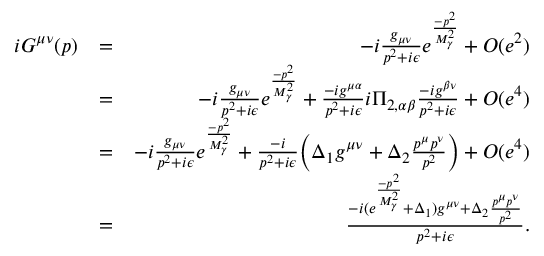<formula> <loc_0><loc_0><loc_500><loc_500>\begin{array} { r l r } { i G ^ { \mu \nu } ( p ) } & { = } & { - i \frac { g _ { \mu \nu } } { p ^ { 2 } + i \epsilon } e ^ { \frac { - p ^ { 2 } } { M _ { \gamma } ^ { 2 } } } + O ( e ^ { 2 } ) } \\ & { = } & { - i \frac { g _ { \mu \nu } } { p ^ { 2 } + i \epsilon } e ^ { \frac { - p ^ { 2 } } { M _ { \gamma } ^ { 2 } } } + \frac { - i g ^ { \mu \alpha } } { p ^ { 2 } + i \epsilon } i \Pi _ { 2 , \alpha \beta } \frac { - i g ^ { \beta \nu } } { p ^ { 2 } + i \epsilon } + O ( e ^ { 4 } ) } \\ & { = } & { - i \frac { g _ { \mu \nu } } { p ^ { 2 } + i \epsilon } e ^ { \frac { - p ^ { 2 } } { M _ { \gamma } ^ { 2 } } } + \frac { - i } { p ^ { 2 } + i \epsilon } \left ( \Delta _ { 1 } g ^ { \mu \nu } + \Delta _ { 2 } \frac { p ^ { \mu } p ^ { \nu } } { p ^ { 2 } } \right ) + O ( e ^ { 4 } ) } \\ & { = } & { \frac { - i ( e ^ { \frac { - p ^ { 2 } } { M _ { \gamma } ^ { 2 } } } + \Delta _ { 1 } ) g ^ { \mu \nu } + \Delta _ { 2 } \frac { p ^ { \mu } p ^ { \nu } } { p ^ { 2 } } } { p ^ { 2 } + i \epsilon } . } \end{array}</formula> 